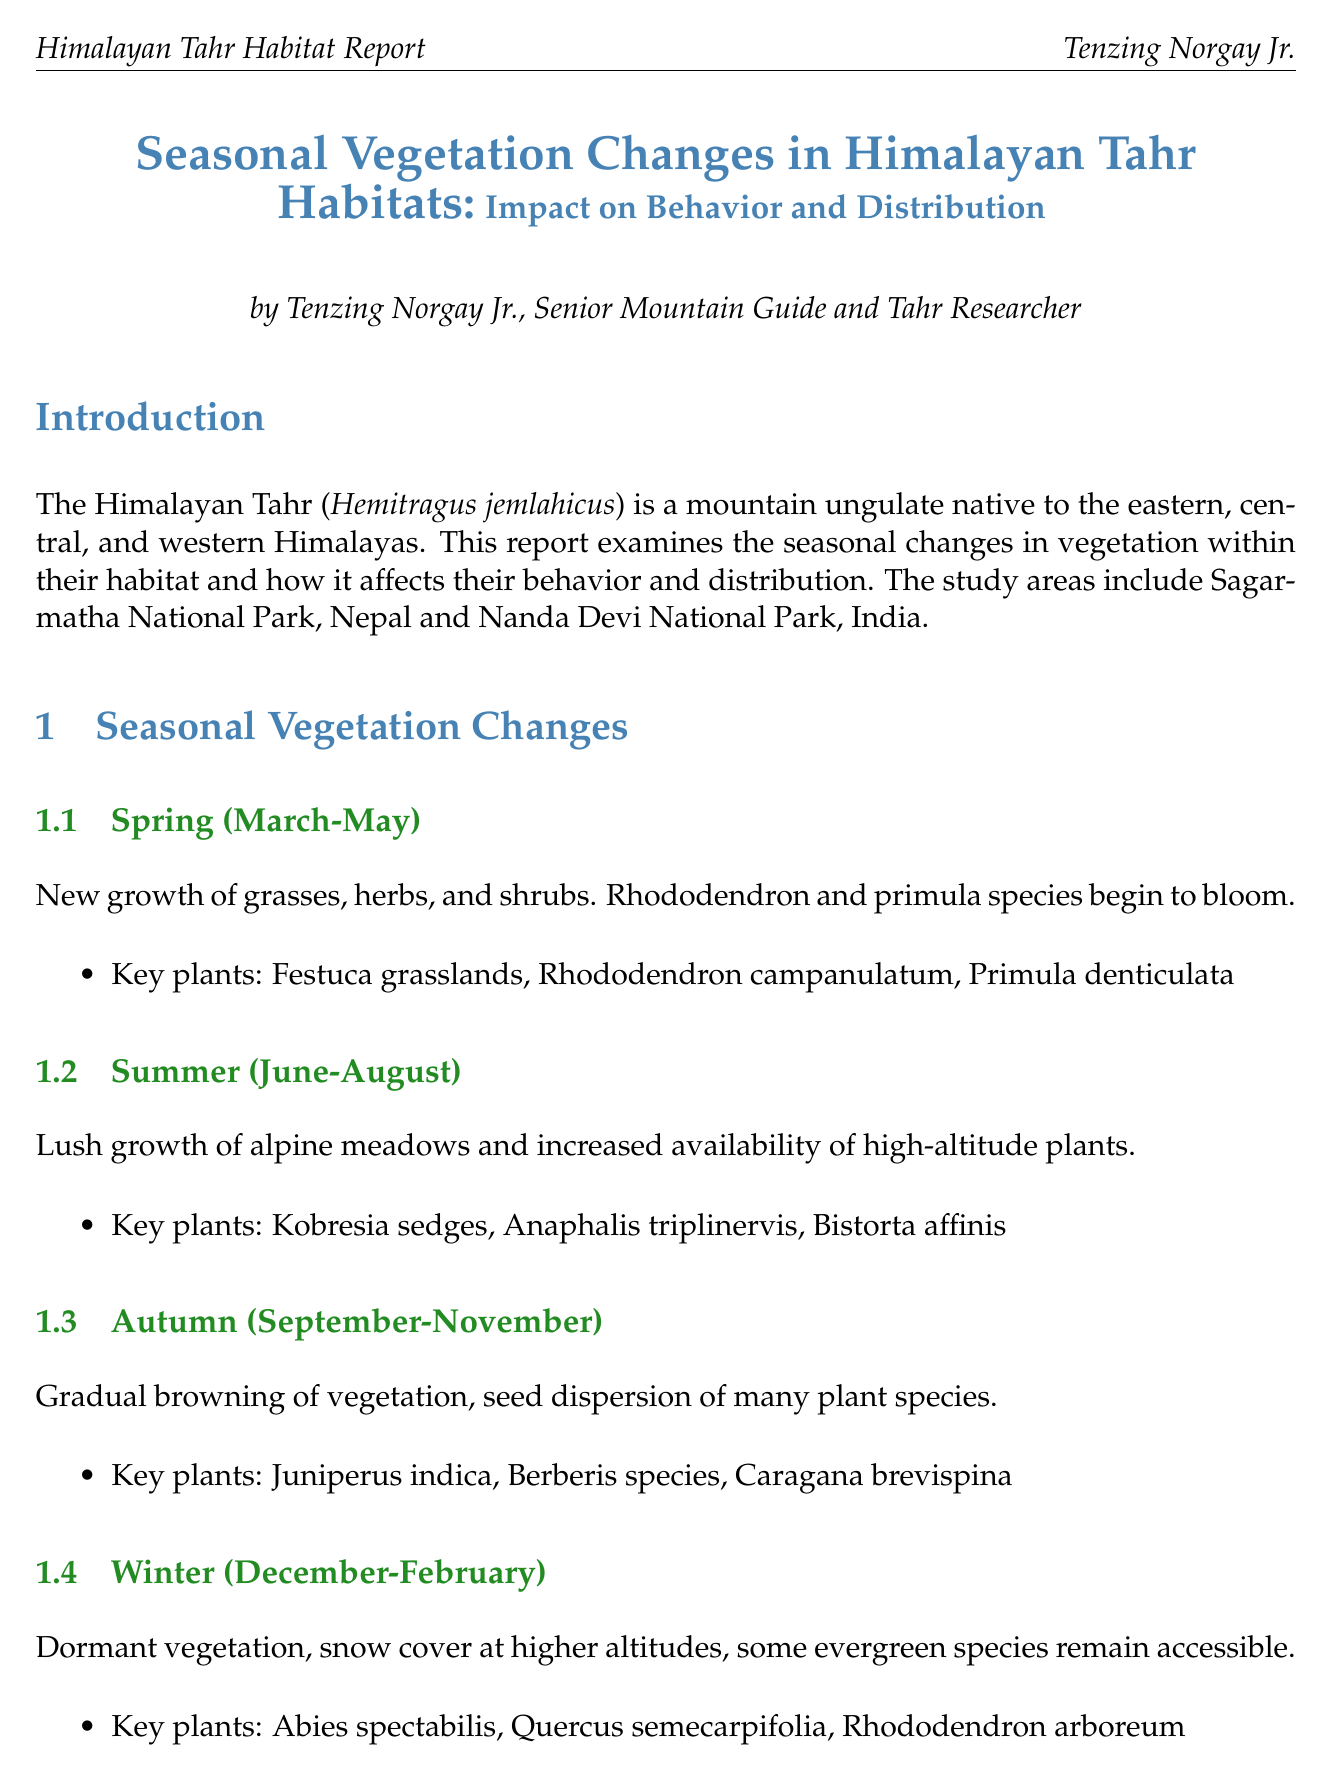What is the title of the report? The title summarizes the content of the report which focuses on seasonal vegetation changes and their impact on the Himalayan Tahr.
Answer: Seasonal Vegetation Changes in Himalayan Tahr Habitats: Impact on Behavior and Distribution Who is the author of the report? The author is credited in the document for their research and expertise related to the Himalayan Tahr.
Answer: Tenzing Norgay Jr What are the key plants listed for Spring? The document provides a list of specific plants that are prominent in the tahr's habitat during the Spring season.
Answer: Festuca grasslands, Rhododendron campanulatum, Primula denticulata In which national parks was the study conducted? The introduction specifies the locations that were examined for the research on tahr habitats.
Answer: Sagarmatha National Park, Nanda Devi National Park What behavior change is observed in Tahr during Winter? The report highlights specific behavioral responses of Tahr to seasonal changes, focusing on Winter.
Answer: Downward migration to lower elevations with less snow What is one conservation implication mentioned in the report? The report discusses various conservation strategies and considerations regarding Tahr habitat.
Answer: Monitoring and protecting key plant species essential for tahr diet across seasons During which season does the rutting season begin for Tahr? The document details significant behavioral changes suited to different seasons, including reproduction behavior.
Answer: Autumn What recommendation is made for future research? The conclusion provides suggestions for further studies to enhance understanding of Tahr behavior and vegetation changes.
Answer: GPS tracking of tahr movements in relation to seasonal vegetation changes 